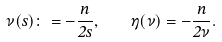Convert formula to latex. <formula><loc_0><loc_0><loc_500><loc_500>\nu ( s ) \colon = - \frac { n } { 2 s } , \quad \eta ( \nu ) = - \frac { n } { 2 \nu } .</formula> 